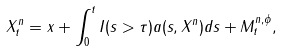Convert formula to latex. <formula><loc_0><loc_0><loc_500><loc_500>X ^ { n } _ { t } = x + \int _ { 0 } ^ { t } I ( s > \tau ) a ( s , X ^ { n } ) d s + M ^ { n , \phi } _ { t } ,</formula> 